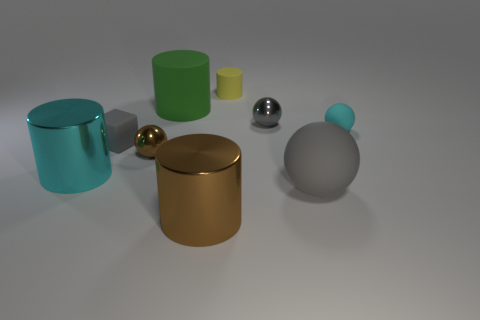How many other objects are the same shape as the small yellow rubber thing? 3 